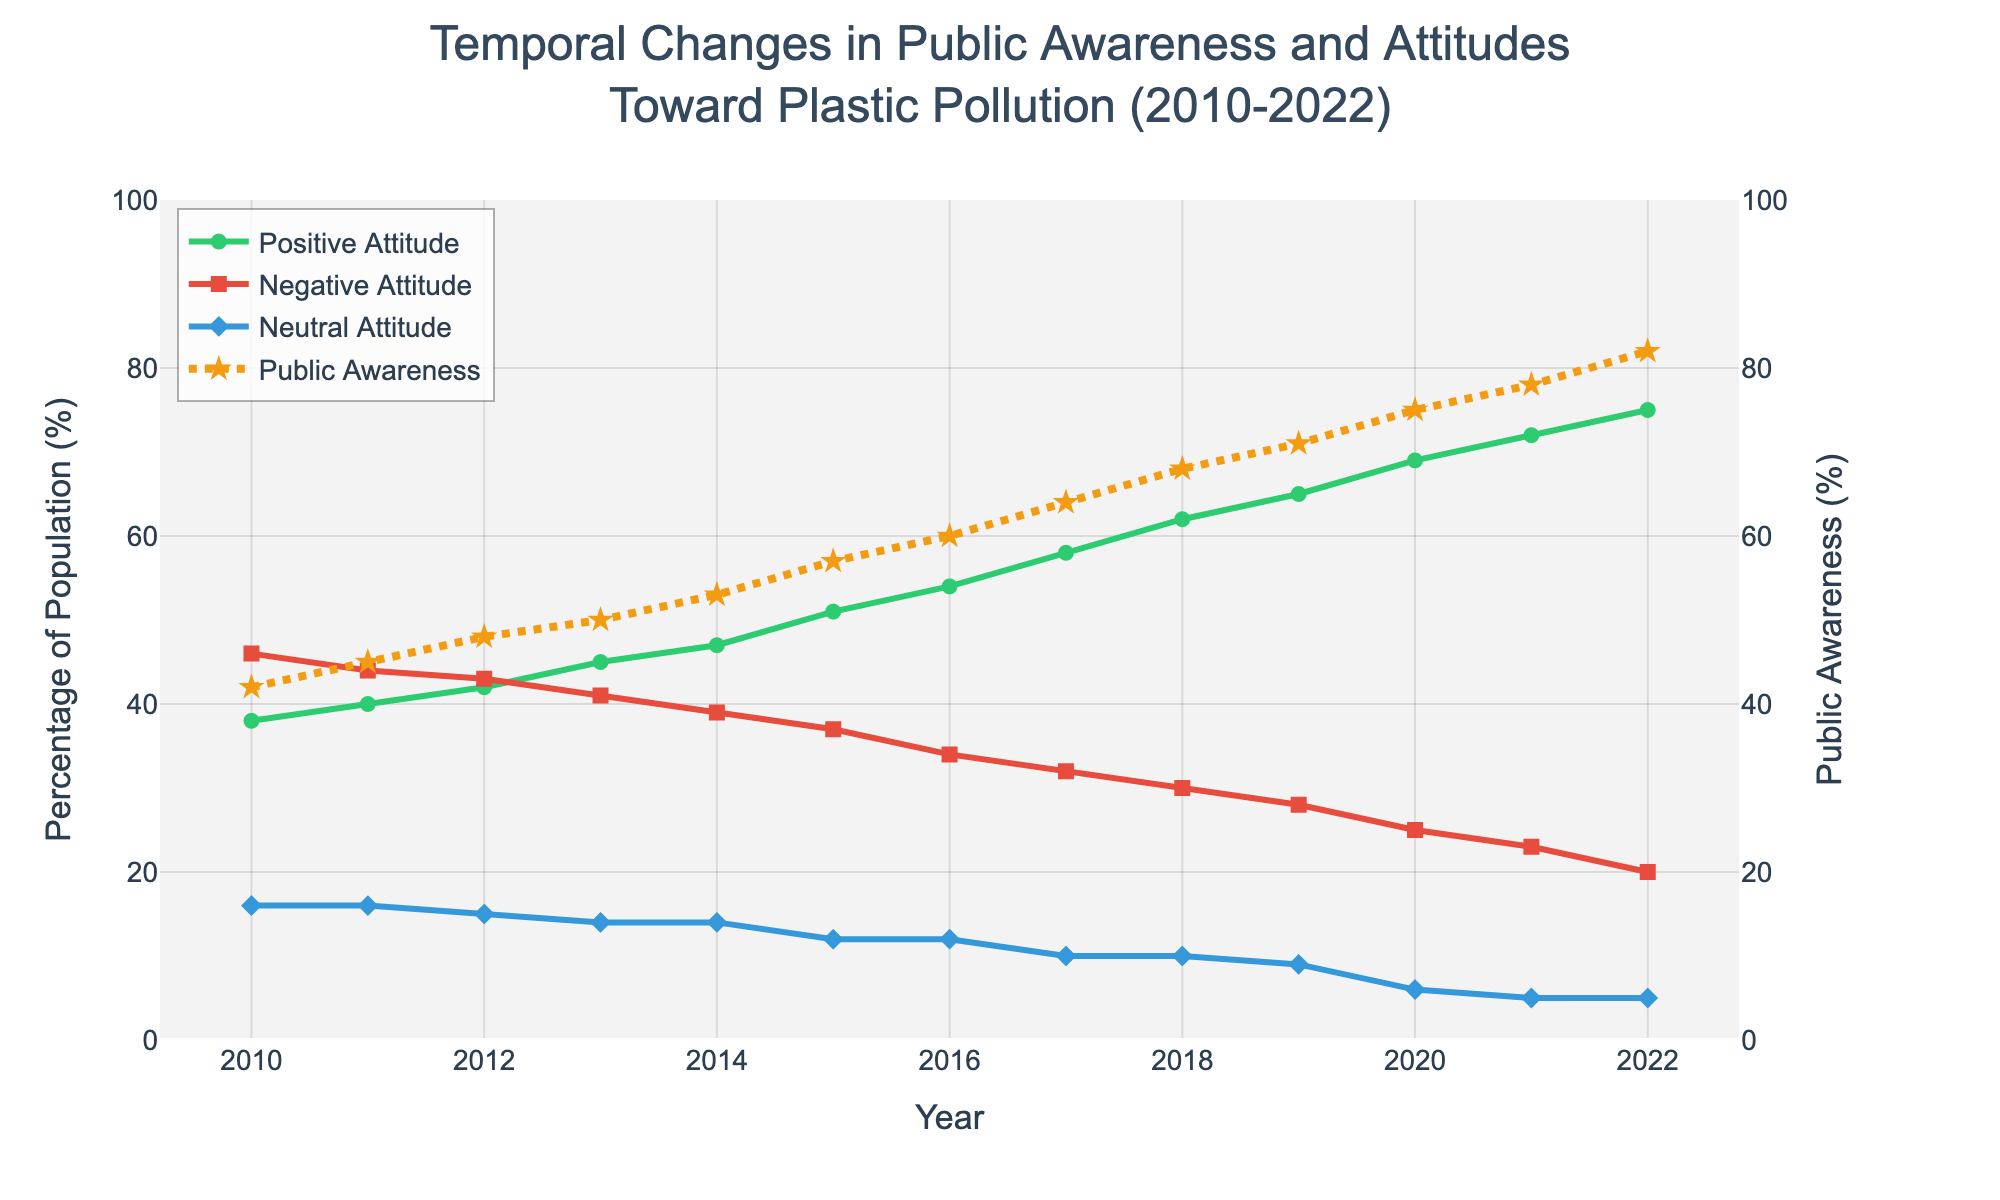What does the title of the plot indicate about the data presented? The title "Temporal Changes in Public Awareness and Attitudes Toward Plastic Pollution (2010-2022)" suggests that the plot shows how public awareness and attitudes (positive, negative, neutral) toward plastic pollution have changed over time from 2010 to 2022.
Answer: Temporal Changes in Public Awareness and Attitudes Toward Plastic Pollution (2010-2022) Which year had the highest public awareness of plastic pollution? From the plot, the highest point on the public awareness line occurs in the year 2022.
Answer: 2022 How did the percentage of the population with a positive attitude toward plastic pollution change from 2010 to 2022? The positive attitude line in the plot starts at 38% in 2010 and ends at 75% in 2022, indicating an increase of 37 percentage points over the period.
Answer: Increased by 37 percentage points What trend can be observed in the neutral attitude toward plastic pollution from 2010 to 2022? The neutral attitude line shows a consistent decreasing trend from 2010 to 2022, starting at 16% and ending at 5%.
Answer: Decreased Between 2010 and 2022, in which year did the gap between positive and negative attitudes toward plastic pollution first exceed 20%? Observing the divergence of the positive and negative attitude lines, the gap first exceeds 20% in the year 2013, where the positive attitude is approximately 45% and negative attitude is around 41%.
Answer: 2013 By how many percentage points did the public awareness about plastic pollution increase per year on average between 2010 and 2022? First, find the total increase in public awareness from 2010 (42%) to 2022 (82%), which is 40 percentage points. Then, divide this by the number of years, which is 12. Thus, the average increase per year is approximately 40/12 ≈ 3.33 percentage points.
Answer: ≈ 3.33 Compare the public awareness about plastic pollution in 2015 to 2020. Which year had a higher awareness and by how much? From the plot, the public awareness in 2015 is 57%, and in 2020 it is 75%. The difference between the two is 75% - 57% = 18 percentage points.
Answer: 2020 by 18 percentage points How does the trend in negative attitude compare to the trend in positive attitude toward plastic pollution from 2010 to 2022? The negative attitude shows a declining trend, decreasing from 46% in 2010 to 20% in 2022, while the positive attitude shows an increasing trend, rising from 38% in 2010 to 75% in 2022.
Answer: Negative attitude declined; positive attitude increased What is the range of neutral attitude percentages from 2010 to 2022? The neutral attitude percentages range from a high of 16% in 2010 to a low of 5% in 2022.
Answer: 5% to 16% 